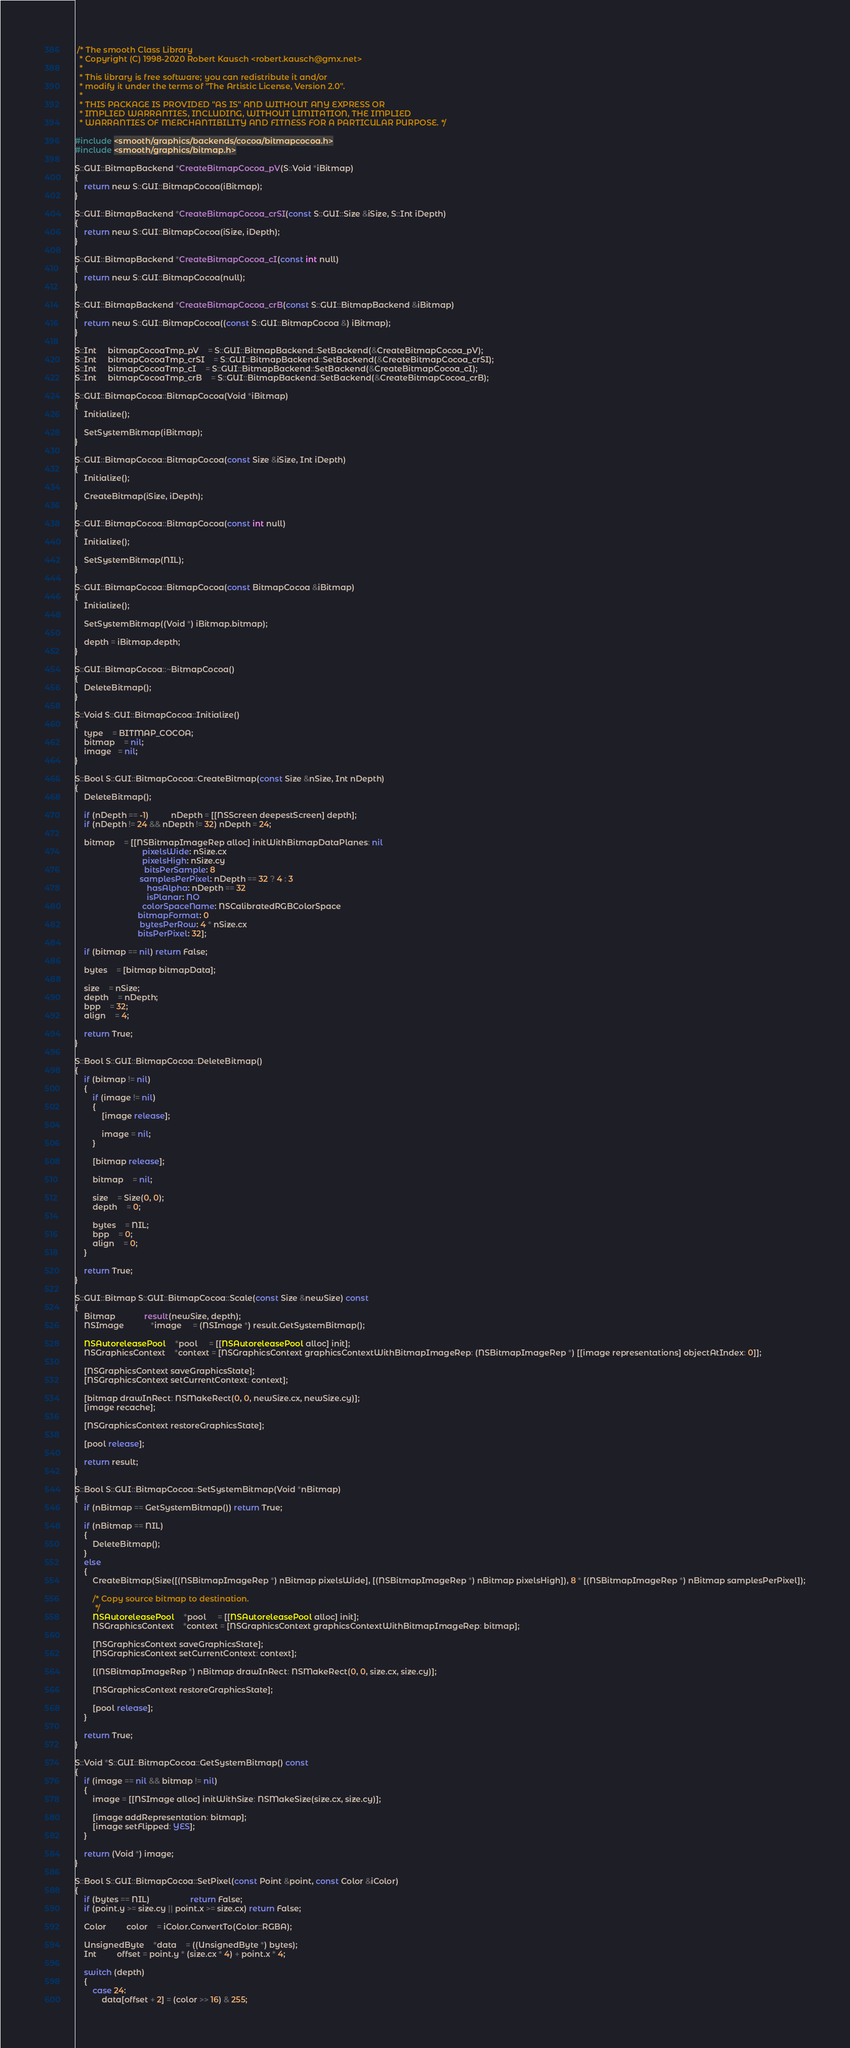Convert code to text. <code><loc_0><loc_0><loc_500><loc_500><_ObjectiveC_> /* The smooth Class Library
  * Copyright (C) 1998-2020 Robert Kausch <robert.kausch@gmx.net>
  *
  * This library is free software; you can redistribute it and/or
  * modify it under the terms of "The Artistic License, Version 2.0".
  *
  * THIS PACKAGE IS PROVIDED "AS IS" AND WITHOUT ANY EXPRESS OR
  * IMPLIED WARRANTIES, INCLUDING, WITHOUT LIMITATION, THE IMPLIED
  * WARRANTIES OF MERCHANTIBILITY AND FITNESS FOR A PARTICULAR PURPOSE. */

#include <smooth/graphics/backends/cocoa/bitmapcocoa.h>
#include <smooth/graphics/bitmap.h>

S::GUI::BitmapBackend *CreateBitmapCocoa_pV(S::Void *iBitmap)
{
	return new S::GUI::BitmapCocoa(iBitmap);
}

S::GUI::BitmapBackend *CreateBitmapCocoa_crSI(const S::GUI::Size &iSize, S::Int iDepth)
{
	return new S::GUI::BitmapCocoa(iSize, iDepth);
}

S::GUI::BitmapBackend *CreateBitmapCocoa_cI(const int null)
{
	return new S::GUI::BitmapCocoa(null);
}

S::GUI::BitmapBackend *CreateBitmapCocoa_crB(const S::GUI::BitmapBackend &iBitmap)
{
	return new S::GUI::BitmapCocoa((const S::GUI::BitmapCocoa &) iBitmap);
}

S::Int	 bitmapCocoaTmp_pV	= S::GUI::BitmapBackend::SetBackend(&CreateBitmapCocoa_pV);
S::Int	 bitmapCocoaTmp_crSI	= S::GUI::BitmapBackend::SetBackend(&CreateBitmapCocoa_crSI);
S::Int	 bitmapCocoaTmp_cI	= S::GUI::BitmapBackend::SetBackend(&CreateBitmapCocoa_cI);
S::Int	 bitmapCocoaTmp_crB	= S::GUI::BitmapBackend::SetBackend(&CreateBitmapCocoa_crB);

S::GUI::BitmapCocoa::BitmapCocoa(Void *iBitmap)
{
	Initialize();

	SetSystemBitmap(iBitmap);
}

S::GUI::BitmapCocoa::BitmapCocoa(const Size &iSize, Int iDepth)
{
	Initialize();

	CreateBitmap(iSize, iDepth);
}

S::GUI::BitmapCocoa::BitmapCocoa(const int null)
{
	Initialize();

	SetSystemBitmap(NIL);
}

S::GUI::BitmapCocoa::BitmapCocoa(const BitmapCocoa &iBitmap)
{
	Initialize();

	SetSystemBitmap((Void *) iBitmap.bitmap);

	depth = iBitmap.depth;
}

S::GUI::BitmapCocoa::~BitmapCocoa()
{
	DeleteBitmap();
}

S::Void S::GUI::BitmapCocoa::Initialize()
{
	type	= BITMAP_COCOA;
	bitmap	= nil;
	image   = nil;
}

S::Bool S::GUI::BitmapCocoa::CreateBitmap(const Size &nSize, Int nDepth)
{
	DeleteBitmap();

	if (nDepth == -1)		  nDepth = [[NSScreen deepestScreen] depth];
	if (nDepth != 24 && nDepth != 32) nDepth = 24;

	bitmap	= [[NSBitmapImageRep alloc] initWithBitmapDataPlanes: nil
							  pixelsWide: nSize.cx
							  pixelsHigh: nSize.cy
						       bitsPerSample: 8
						     samplesPerPixel: nDepth == 32 ? 4 : 3
							    hasAlpha: nDepth == 32
							    isPlanar: NO
						      colorSpaceName: NSCalibratedRGBColorSpace
							bitmapFormat: 0
							 bytesPerRow: 4 * nSize.cx
							bitsPerPixel: 32];

	if (bitmap == nil) return False;

	bytes	= [bitmap bitmapData];

	size	= nSize;
	depth	= nDepth;
	bpp	= 32;
	align	= 4;

	return True;
}

S::Bool S::GUI::BitmapCocoa::DeleteBitmap()
{
	if (bitmap != nil)
	{
		if (image != nil)
		{
			[image release];

			image = nil;
		}

		[bitmap release];

		bitmap	= nil;

		size	= Size(0, 0);
		depth	= 0;

		bytes	= NIL;
		bpp	= 0;
		align	= 0;
	}

	return True;
}

S::GUI::Bitmap S::GUI::BitmapCocoa::Scale(const Size &newSize) const
{
	Bitmap			 result(newSize, depth);
	NSImage			*image	 = (NSImage *) result.GetSystemBitmap();

	NSAutoreleasePool	*pool	 = [[NSAutoreleasePool alloc] init];
	NSGraphicsContext	*context = [NSGraphicsContext graphicsContextWithBitmapImageRep: (NSBitmapImageRep *) [[image representations] objectAtIndex: 0]];

	[NSGraphicsContext saveGraphicsState];
	[NSGraphicsContext setCurrentContext: context];

	[bitmap drawInRect: NSMakeRect(0, 0, newSize.cx, newSize.cy)];
	[image recache];

	[NSGraphicsContext restoreGraphicsState];

	[pool release];

	return result;
}

S::Bool S::GUI::BitmapCocoa::SetSystemBitmap(Void *nBitmap)
{
	if (nBitmap == GetSystemBitmap()) return True;

	if (nBitmap == NIL)
	{
		DeleteBitmap();
	}
	else
	{
		CreateBitmap(Size([(NSBitmapImageRep *) nBitmap pixelsWide], [(NSBitmapImageRep *) nBitmap pixelsHigh]), 8 * [(NSBitmapImageRep *) nBitmap samplesPerPixel]);

		/* Copy source bitmap to destination.
		 */
		NSAutoreleasePool	*pool	 = [[NSAutoreleasePool alloc] init];
		NSGraphicsContext	*context = [NSGraphicsContext graphicsContextWithBitmapImageRep: bitmap];

		[NSGraphicsContext saveGraphicsState];
		[NSGraphicsContext setCurrentContext: context];

		[(NSBitmapImageRep *) nBitmap drawInRect: NSMakeRect(0, 0, size.cx, size.cy)];

		[NSGraphicsContext restoreGraphicsState];

		[pool release];
	}

	return True;
}

S::Void *S::GUI::BitmapCocoa::GetSystemBitmap() const
{
	if (image == nil && bitmap != nil)
	{
		image = [[NSImage alloc] initWithSize: NSMakeSize(size.cx, size.cy)];

		[image addRepresentation: bitmap];
		[image setFlipped: YES];
	}

	return (Void *) image;
}

S::Bool S::GUI::BitmapCocoa::SetPixel(const Point &point, const Color &iColor)
{
	if (bytes == NIL)			      return False;
	if (point.y >= size.cy || point.x >= size.cx) return False;

	Color		 color	= iColor.ConvertTo(Color::RGBA);

	UnsignedByte	*data	= ((UnsignedByte *) bytes);
	Int		 offset = point.y * (size.cx * 4) + point.x * 4;

	switch (depth)
	{
		case 24:
			data[offset + 2] = (color >> 16) & 255;</code> 